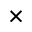Convert formula to latex. <formula><loc_0><loc_0><loc_500><loc_500>\times</formula> 